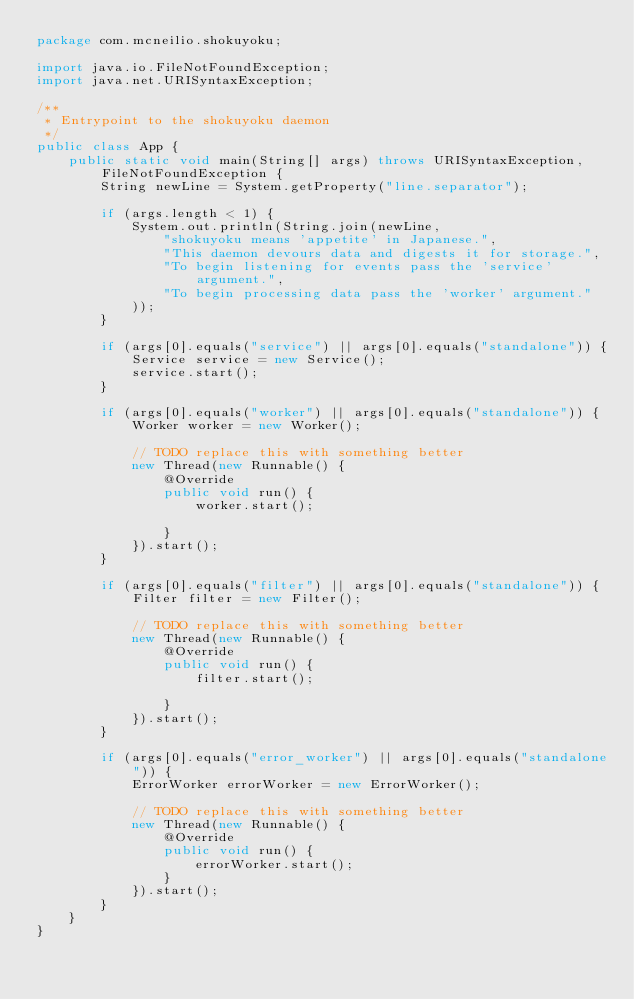<code> <loc_0><loc_0><loc_500><loc_500><_Java_>package com.mcneilio.shokuyoku;

import java.io.FileNotFoundException;
import java.net.URISyntaxException;

/**
 * Entrypoint to the shokuyoku daemon
 */
public class App {
    public static void main(String[] args) throws URISyntaxException, FileNotFoundException {
        String newLine = System.getProperty("line.separator");

        if (args.length < 1) {
            System.out.println(String.join(newLine,
                "shokuyoku means 'appetite' in Japanese.",
                "This daemon devours data and digests it for storage.",
                "To begin listening for events pass the 'service' argument.",
                "To begin processing data pass the 'worker' argument."
            ));
        }

        if (args[0].equals("service") || args[0].equals("standalone")) {
            Service service = new Service();
            service.start();
        }

        if (args[0].equals("worker") || args[0].equals("standalone")) {
            Worker worker = new Worker();

            // TODO replace this with something better
            new Thread(new Runnable() {
                @Override
                public void run() {
                    worker.start();

                }
            }).start();
        }

        if (args[0].equals("filter") || args[0].equals("standalone")) {
            Filter filter = new Filter();

            // TODO replace this with something better
            new Thread(new Runnable() {
                @Override
                public void run() {
                    filter.start();

                }
            }).start();
        }

        if (args[0].equals("error_worker") || args[0].equals("standalone")) {
            ErrorWorker errorWorker = new ErrorWorker();

            // TODO replace this with something better
            new Thread(new Runnable() {
                @Override
                public void run() {
                    errorWorker.start();
                }
            }).start();
        }
    }
}
</code> 